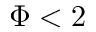<formula> <loc_0><loc_0><loc_500><loc_500>\Phi < 2</formula> 